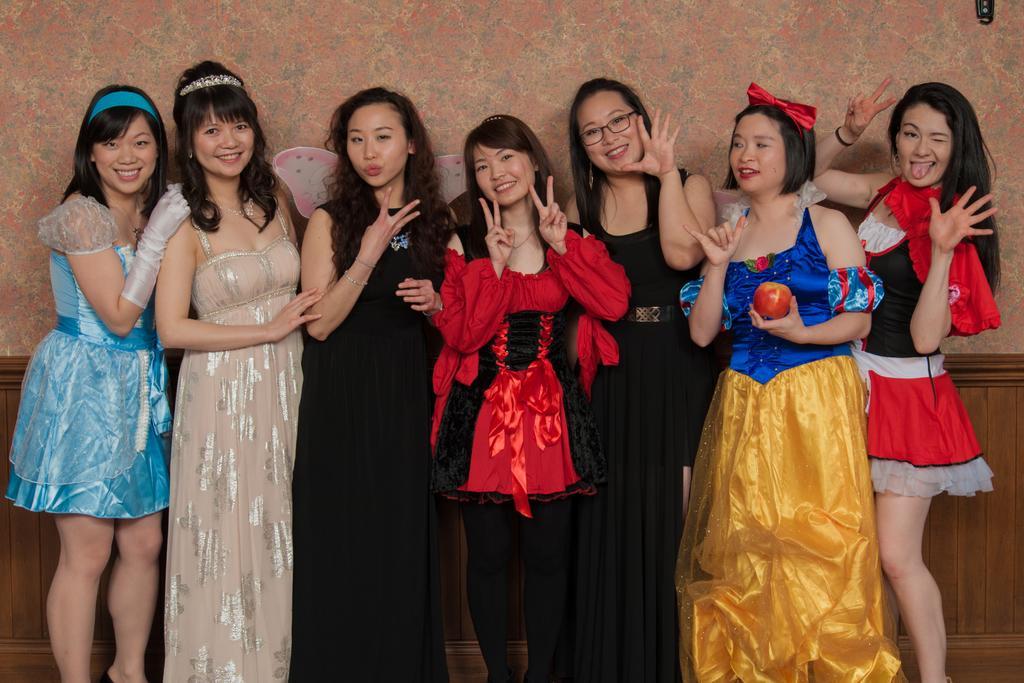Please provide a concise description of this image. Here in this picture we can see a group of women standing over a place and they are posing for a picture and smiling. 